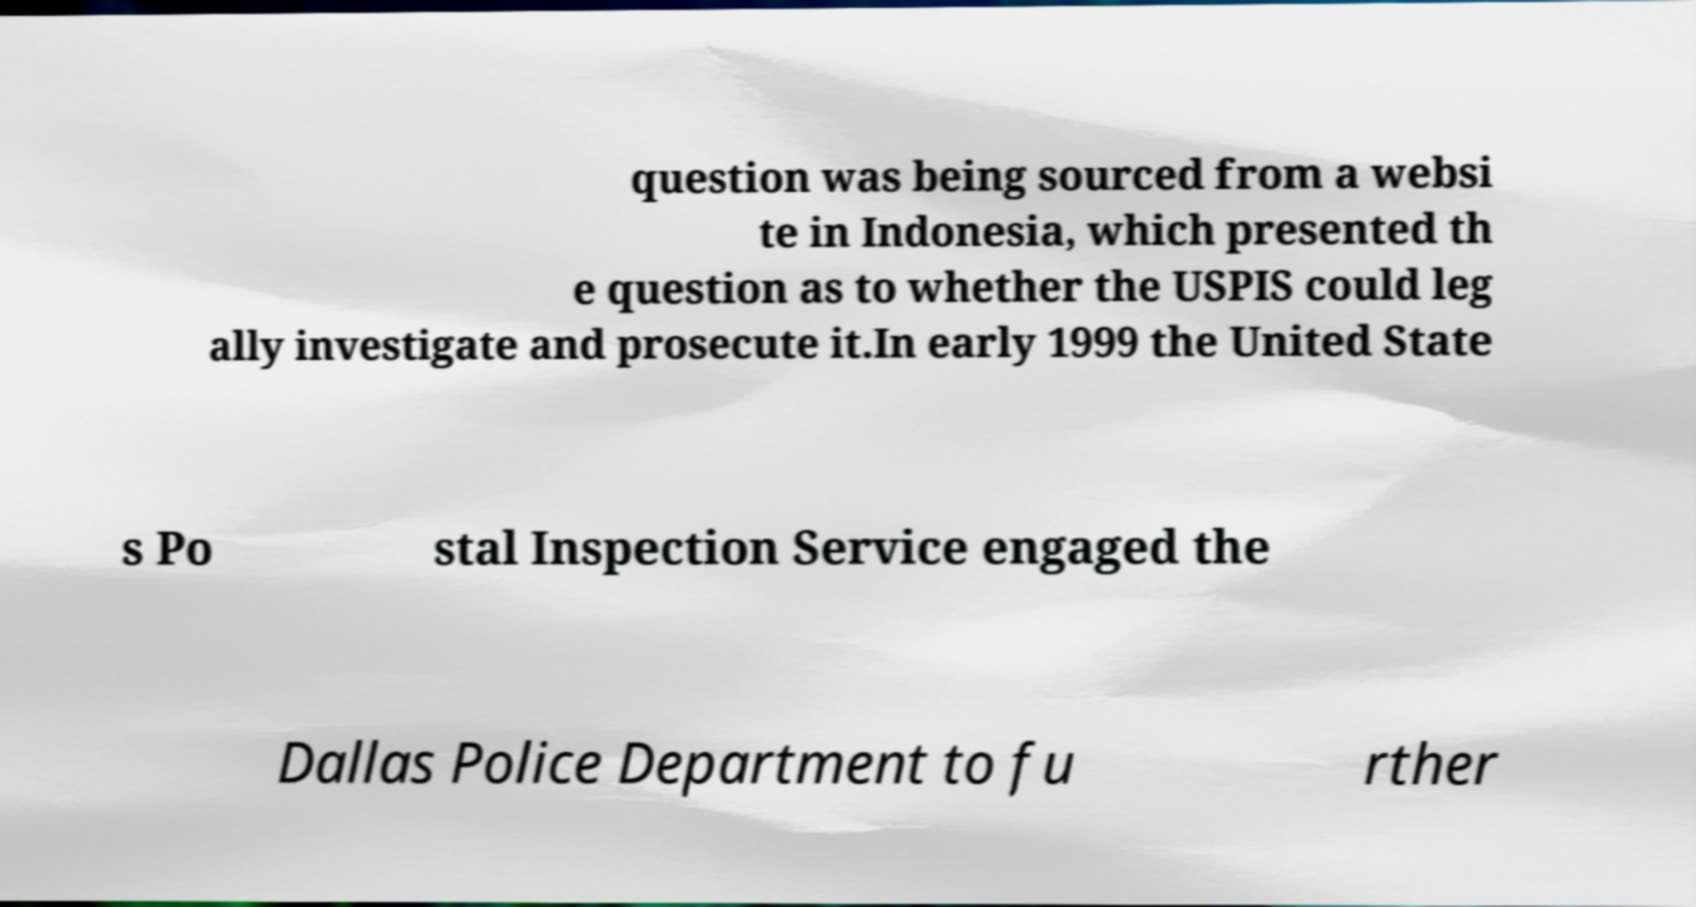Could you assist in decoding the text presented in this image and type it out clearly? question was being sourced from a websi te in Indonesia, which presented th e question as to whether the USPIS could leg ally investigate and prosecute it.In early 1999 the United State s Po stal Inspection Service engaged the Dallas Police Department to fu rther 